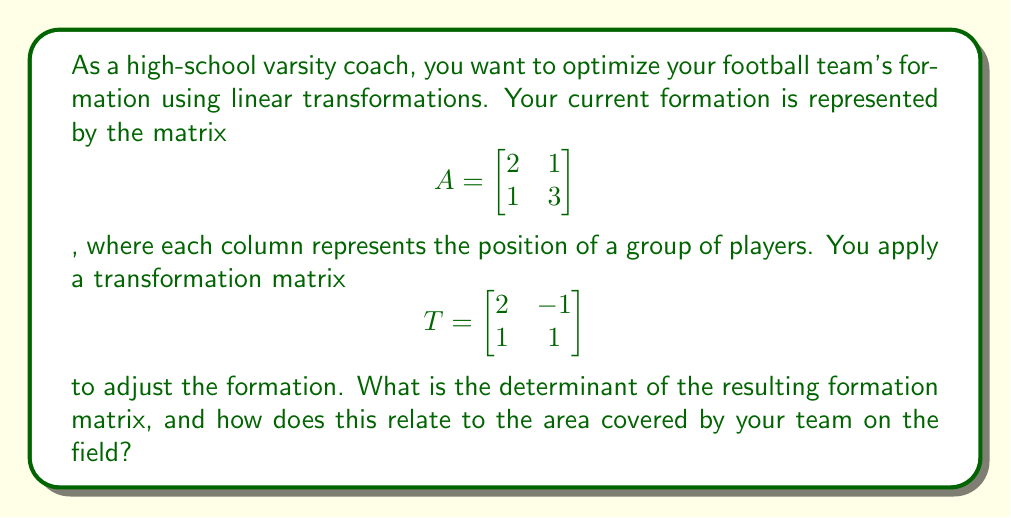Teach me how to tackle this problem. To solve this problem, we'll follow these steps:

1) First, we need to multiply the transformation matrix $T$ by the original formation matrix $A$. The resulting matrix will represent the new formation.

   $$TA = \begin{bmatrix} 2 & -1 \\ 1 & 1 \end{bmatrix} \begin{bmatrix} 2 & 1 \\ 1 & 3 \end{bmatrix}$$

2) Let's perform the matrix multiplication:

   $$TA = \begin{bmatrix} (2 \cdot 2 + (-1) \cdot 1) & (2 \cdot 1 + (-1) \cdot 3) \\ (1 \cdot 2 + 1 \cdot 1) & (1 \cdot 1 + 1 \cdot 3) \end{bmatrix}$$

   $$TA = \begin{bmatrix} 3 & -1 \\ 3 & 4 \end{bmatrix}$$

3) Now, we need to find the determinant of this new formation matrix. The determinant of a 2x2 matrix $$\begin{bmatrix} a & b \\ c & d \end{bmatrix}$$ is calculated as $ad - bc$.

4) For our resulting matrix:

   $$det(TA) = (3 \cdot 4) - (-1 \cdot 3) = 12 + 3 = 15$$

5) The determinant of a transformation matrix represents the factor by which the transformation scales the area of any shape. In this case, the determinant is 15, which means the area covered by the team on the field has been scaled by a factor of 15.

6) To verify this, we can calculate the determinants of $T$ and $A$ separately:

   $$det(T) = (2 \cdot 1) - (-1 \cdot 1) = 3$$
   $$det(A) = (2 \cdot 3) - (1 \cdot 1) = 5$$

   And indeed, $det(T) \cdot det(A) = 3 \cdot 5 = 15 = det(TA)$

This demonstrates that the new formation covers 15 times the area of the original formation, potentially allowing for better field coverage and strategic advantages.
Answer: 15; area scaled by factor of 15 